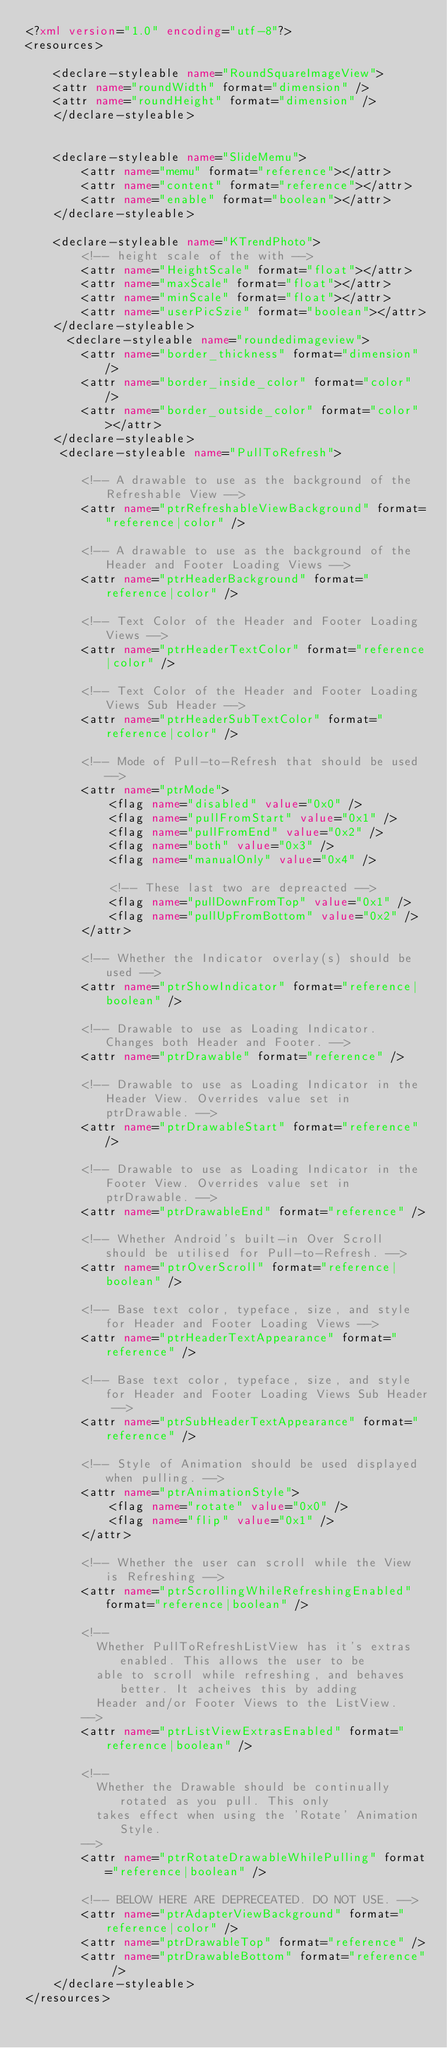<code> <loc_0><loc_0><loc_500><loc_500><_XML_><?xml version="1.0" encoding="utf-8"?>
<resources>

    <declare-styleable name="RoundSquareImageView">
    <attr name="roundWidth" format="dimension" />
    <attr name="roundHeight" format="dimension" />
    </declare-styleable>
    

    <declare-styleable name="SlideMemu">
        <attr name="memu" format="reference"></attr>
        <attr name="content" format="reference"></attr>
        <attr name="enable" format="boolean"></attr>
    </declare-styleable>
    
    <declare-styleable name="KTrendPhoto">
        <!-- height scale of the with -->
        <attr name="HeightScale" format="float"></attr>
        <attr name="maxScale" format="float"></attr>
        <attr name="minScale" format="float"></attr>
        <attr name="userPicSzie" format="boolean"></attr>
    </declare-styleable>
      <declare-styleable name="roundedimageview">
        <attr name="border_thickness" format="dimension" />
        <attr name="border_inside_color" format="color" />
        <attr name="border_outside_color" format="color"></attr>
    </declare-styleable>
     <declare-styleable name="PullToRefresh">

        <!-- A drawable to use as the background of the Refreshable View -->
        <attr name="ptrRefreshableViewBackground" format="reference|color" />

        <!-- A drawable to use as the background of the Header and Footer Loading Views -->
        <attr name="ptrHeaderBackground" format="reference|color" />

        <!-- Text Color of the Header and Footer Loading Views -->
        <attr name="ptrHeaderTextColor" format="reference|color" />

        <!-- Text Color of the Header and Footer Loading Views Sub Header -->
        <attr name="ptrHeaderSubTextColor" format="reference|color" />

        <!-- Mode of Pull-to-Refresh that should be used -->
        <attr name="ptrMode">
            <flag name="disabled" value="0x0" />
            <flag name="pullFromStart" value="0x1" />
            <flag name="pullFromEnd" value="0x2" />
            <flag name="both" value="0x3" />
            <flag name="manualOnly" value="0x4" />

            <!-- These last two are depreacted -->
            <flag name="pullDownFromTop" value="0x1" />
            <flag name="pullUpFromBottom" value="0x2" />
        </attr>

        <!-- Whether the Indicator overlay(s) should be used -->
        <attr name="ptrShowIndicator" format="reference|boolean" />

        <!-- Drawable to use as Loading Indicator. Changes both Header and Footer. -->
        <attr name="ptrDrawable" format="reference" />

        <!-- Drawable to use as Loading Indicator in the Header View. Overrides value set in ptrDrawable. -->
        <attr name="ptrDrawableStart" format="reference" />

        <!-- Drawable to use as Loading Indicator in the Footer View. Overrides value set in ptrDrawable. -->
        <attr name="ptrDrawableEnd" format="reference" />

        <!-- Whether Android's built-in Over Scroll should be utilised for Pull-to-Refresh. -->
        <attr name="ptrOverScroll" format="reference|boolean" />

        <!-- Base text color, typeface, size, and style for Header and Footer Loading Views -->
        <attr name="ptrHeaderTextAppearance" format="reference" />

        <!-- Base text color, typeface, size, and style for Header and Footer Loading Views Sub Header -->
        <attr name="ptrSubHeaderTextAppearance" format="reference" />

        <!-- Style of Animation should be used displayed when pulling. -->
        <attr name="ptrAnimationStyle">
            <flag name="rotate" value="0x0" />
            <flag name="flip" value="0x1" />
        </attr>

        <!-- Whether the user can scroll while the View is Refreshing -->
        <attr name="ptrScrollingWhileRefreshingEnabled" format="reference|boolean" />

        <!--
        	Whether PullToRefreshListView has it's extras enabled. This allows the user to be 
        	able to scroll while refreshing, and behaves better. It acheives this by adding
        	Header and/or Footer Views to the ListView.
        -->
        <attr name="ptrListViewExtrasEnabled" format="reference|boolean" />

        <!--
        	Whether the Drawable should be continually rotated as you pull. This only
        	takes effect when using the 'Rotate' Animation Style.
        -->
        <attr name="ptrRotateDrawableWhilePulling" format="reference|boolean" />

        <!-- BELOW HERE ARE DEPRECEATED. DO NOT USE. -->
        <attr name="ptrAdapterViewBackground" format="reference|color" />
        <attr name="ptrDrawableTop" format="reference" />
        <attr name="ptrDrawableBottom" format="reference" />
    </declare-styleable>
</resources></code> 